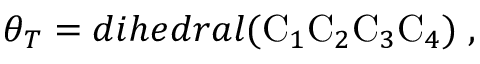<formula> <loc_0><loc_0><loc_500><loc_500>\theta _ { T } = d i h e d r a l ( C _ { 1 } C _ { 2 } C _ { 3 } C _ { 4 } ) \, ,</formula> 